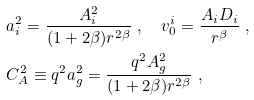<formula> <loc_0><loc_0><loc_500><loc_500>& a _ { i } ^ { 2 } = \frac { A _ { i } ^ { 2 } } { ( 1 + 2 \beta ) r ^ { 2 \beta } } \ , \quad v _ { 0 } ^ { i } = \frac { A _ { i } D _ { i } } { r ^ { \beta } } \ , \\ & C _ { A } ^ { 2 } \equiv q ^ { 2 } a _ { g } ^ { 2 } = \frac { q ^ { 2 } A _ { g } ^ { 2 } } { ( 1 + 2 \beta ) r ^ { 2 \beta } } \ ,</formula> 